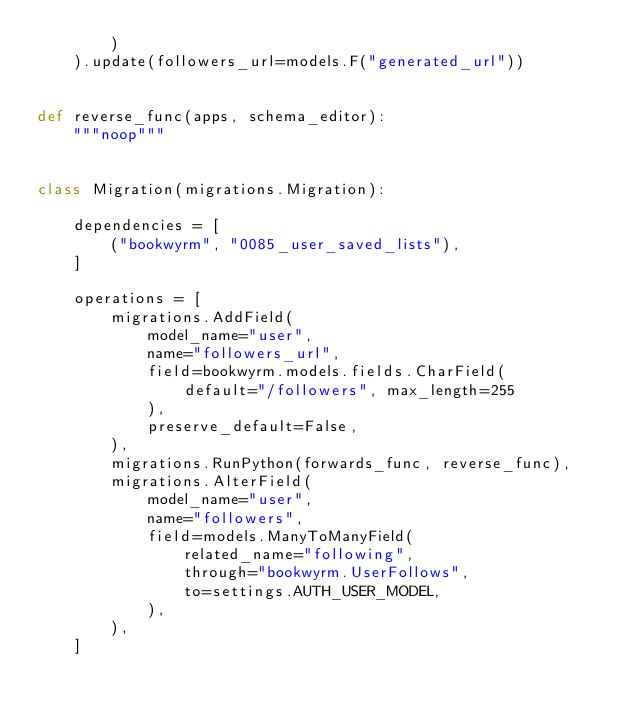Convert code to text. <code><loc_0><loc_0><loc_500><loc_500><_Python_>        )
    ).update(followers_url=models.F("generated_url"))


def reverse_func(apps, schema_editor):
    """noop"""


class Migration(migrations.Migration):

    dependencies = [
        ("bookwyrm", "0085_user_saved_lists"),
    ]

    operations = [
        migrations.AddField(
            model_name="user",
            name="followers_url",
            field=bookwyrm.models.fields.CharField(
                default="/followers", max_length=255
            ),
            preserve_default=False,
        ),
        migrations.RunPython(forwards_func, reverse_func),
        migrations.AlterField(
            model_name="user",
            name="followers",
            field=models.ManyToManyField(
                related_name="following",
                through="bookwyrm.UserFollows",
                to=settings.AUTH_USER_MODEL,
            ),
        ),
    ]
</code> 